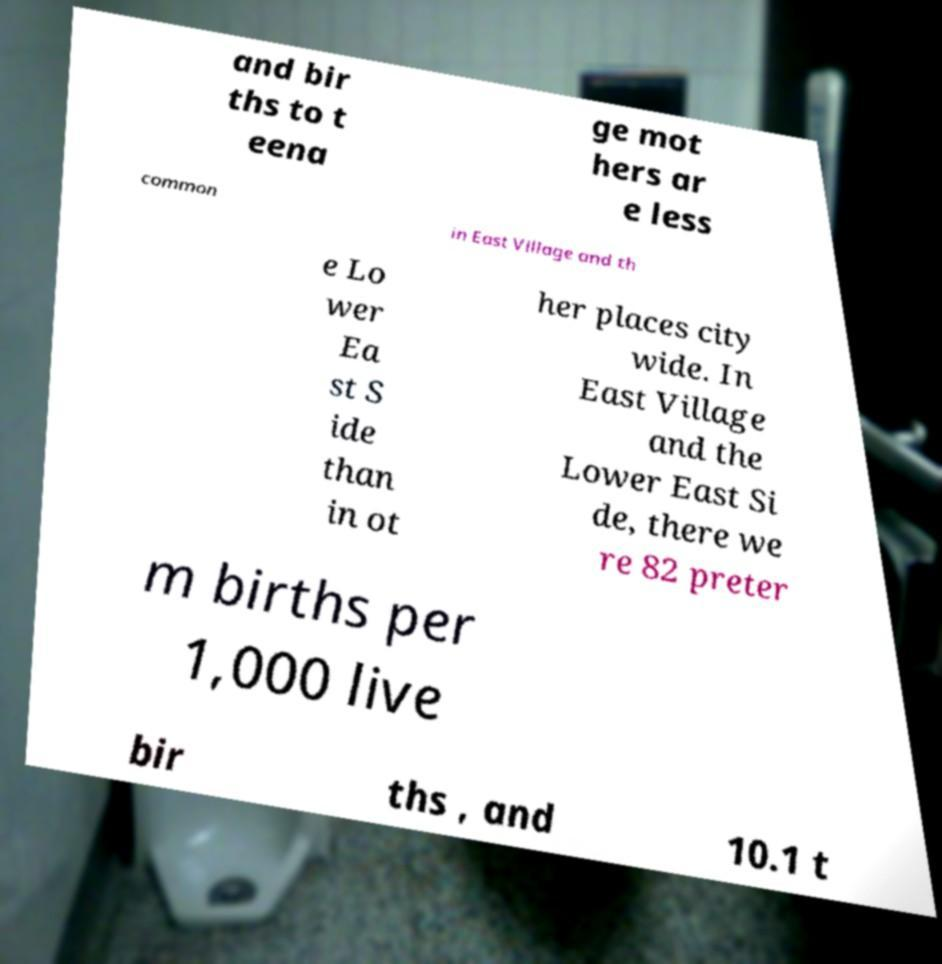There's text embedded in this image that I need extracted. Can you transcribe it verbatim? and bir ths to t eena ge mot hers ar e less common in East Village and th e Lo wer Ea st S ide than in ot her places city wide. In East Village and the Lower East Si de, there we re 82 preter m births per 1,000 live bir ths , and 10.1 t 